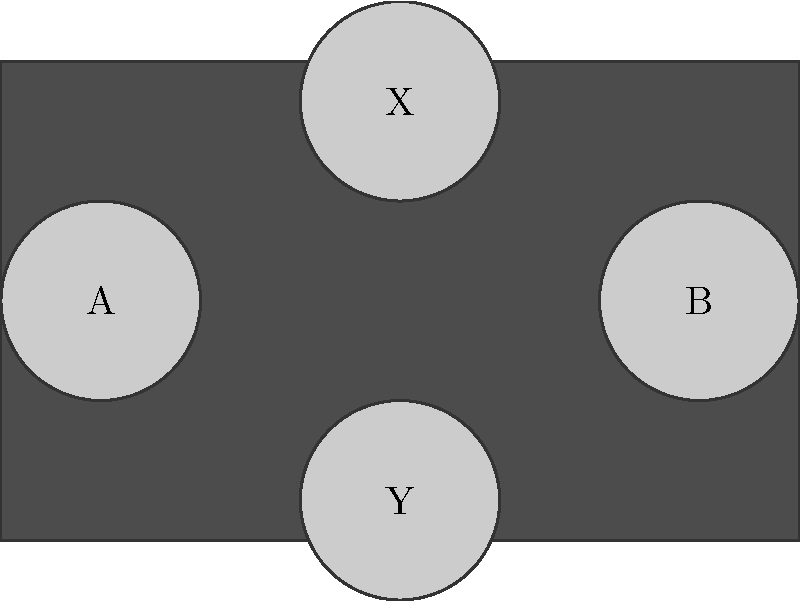As an eSports player, you're analyzing the symmetry of a game controller's button layout. The controller has four buttons arranged in a cross pattern, labeled A, B, X, and Y as shown in the diagram. What is the order of the symmetry group for this button configuration, considering all possible rotations and reflections that preserve the layout? Let's approach this step-by-step:

1) First, we need to identify all the symmetries of this configuration:

   a) Identity (no change)
   b) 90° clockwise rotation
   c) 180° rotation
   d) 270° clockwise rotation (or 90° counterclockwise)
   e) Reflection across the vertical axis
   f) Reflection across the horizontal axis
   g) Reflection across the diagonal from top-left to bottom-right
   h) Reflection across the diagonal from top-right to bottom-left

2) Each of these operations preserves the layout of the buttons, although it may change their labels.

3) We can verify that these 8 operations form a group:
   - They are closed (applying any two operations results in another operation in the set)
   - They are associative
   - The identity element exists (operation a)
   - Each operation has an inverse (which is also in the set)

4) In group theory, the number of elements in a group is called its order.

5) Therefore, the order of this symmetry group is 8.

This group is isomorphic to the dihedral group $D_4$, which is the symmetry group of a square.
Answer: 8 